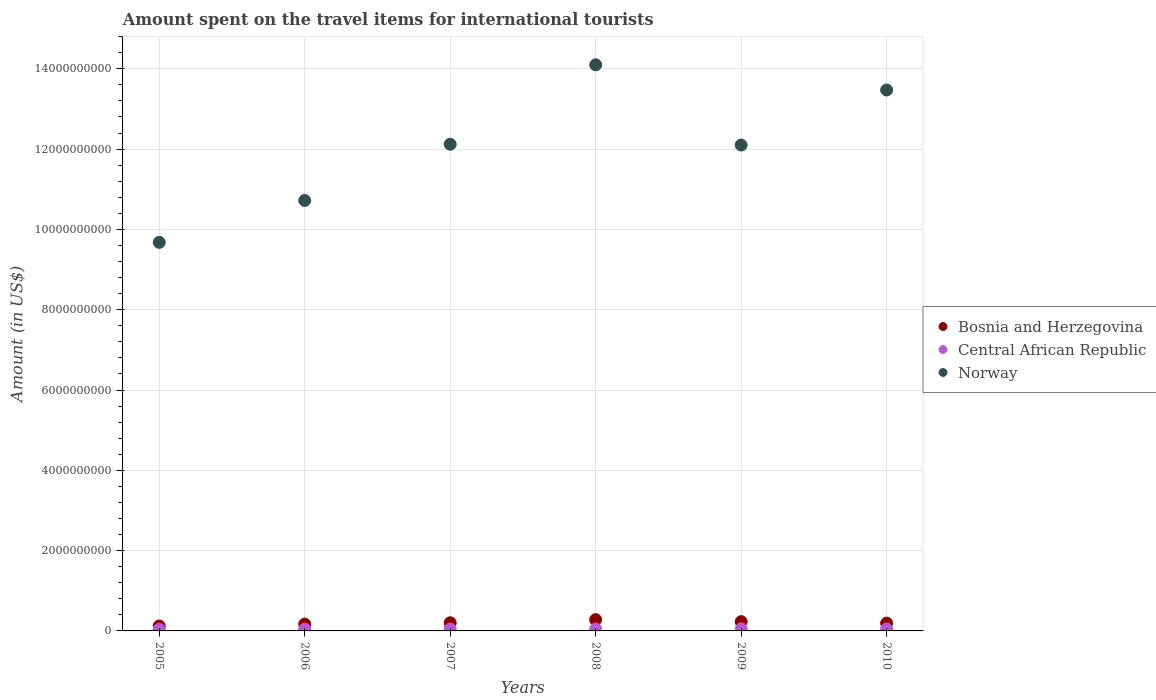How many different coloured dotlines are there?
Keep it short and to the point. 3. What is the amount spent on the travel items for international tourists in Bosnia and Herzegovina in 2008?
Offer a very short reply. 2.81e+08. Across all years, what is the maximum amount spent on the travel items for international tourists in Central African Republic?
Your answer should be very brief. 5.20e+07. Across all years, what is the minimum amount spent on the travel items for international tourists in Norway?
Provide a short and direct response. 9.68e+09. In which year was the amount spent on the travel items for international tourists in Bosnia and Herzegovina minimum?
Ensure brevity in your answer.  2005. What is the total amount spent on the travel items for international tourists in Norway in the graph?
Make the answer very short. 7.22e+1. What is the difference between the amount spent on the travel items for international tourists in Norway in 2005 and the amount spent on the travel items for international tourists in Bosnia and Herzegovina in 2008?
Offer a very short reply. 9.40e+09. What is the average amount spent on the travel items for international tourists in Norway per year?
Your answer should be compact. 1.20e+1. In the year 2009, what is the difference between the amount spent on the travel items for international tourists in Central African Republic and amount spent on the travel items for international tourists in Norway?
Offer a terse response. -1.20e+1. In how many years, is the amount spent on the travel items for international tourists in Central African Republic greater than 14000000000 US$?
Offer a very short reply. 0. What is the ratio of the amount spent on the travel items for international tourists in Bosnia and Herzegovina in 2007 to that in 2008?
Your answer should be very brief. 0.72. Is the amount spent on the travel items for international tourists in Bosnia and Herzegovina in 2005 less than that in 2008?
Keep it short and to the point. Yes. Is the difference between the amount spent on the travel items for international tourists in Central African Republic in 2006 and 2010 greater than the difference between the amount spent on the travel items for international tourists in Norway in 2006 and 2010?
Provide a short and direct response. Yes. What is the difference between the highest and the second highest amount spent on the travel items for international tourists in Bosnia and Herzegovina?
Your response must be concise. 5.00e+07. What is the difference between the highest and the lowest amount spent on the travel items for international tourists in Norway?
Offer a very short reply. 4.42e+09. Is it the case that in every year, the sum of the amount spent on the travel items for international tourists in Bosnia and Herzegovina and amount spent on the travel items for international tourists in Central African Republic  is greater than the amount spent on the travel items for international tourists in Norway?
Provide a succinct answer. No. Does the amount spent on the travel items for international tourists in Central African Republic monotonically increase over the years?
Your answer should be compact. No. Is the amount spent on the travel items for international tourists in Bosnia and Herzegovina strictly greater than the amount spent on the travel items for international tourists in Central African Republic over the years?
Your response must be concise. Yes. Is the amount spent on the travel items for international tourists in Central African Republic strictly less than the amount spent on the travel items for international tourists in Bosnia and Herzegovina over the years?
Your response must be concise. Yes. How many years are there in the graph?
Keep it short and to the point. 6. What is the difference between two consecutive major ticks on the Y-axis?
Your answer should be compact. 2.00e+09. Does the graph contain any zero values?
Ensure brevity in your answer.  No. Does the graph contain grids?
Your response must be concise. Yes. Where does the legend appear in the graph?
Provide a short and direct response. Center right. What is the title of the graph?
Provide a succinct answer. Amount spent on the travel items for international tourists. Does "Barbados" appear as one of the legend labels in the graph?
Keep it short and to the point. No. What is the label or title of the X-axis?
Your answer should be compact. Years. What is the label or title of the Y-axis?
Offer a terse response. Amount (in US$). What is the Amount (in US$) in Bosnia and Herzegovina in 2005?
Your response must be concise. 1.22e+08. What is the Amount (in US$) of Central African Republic in 2005?
Your response must be concise. 4.40e+07. What is the Amount (in US$) in Norway in 2005?
Make the answer very short. 9.68e+09. What is the Amount (in US$) of Bosnia and Herzegovina in 2006?
Keep it short and to the point. 1.70e+08. What is the Amount (in US$) of Central African Republic in 2006?
Your response must be concise. 4.40e+07. What is the Amount (in US$) of Norway in 2006?
Offer a very short reply. 1.07e+1. What is the Amount (in US$) of Bosnia and Herzegovina in 2007?
Keep it short and to the point. 2.03e+08. What is the Amount (in US$) in Central African Republic in 2007?
Provide a short and direct response. 4.80e+07. What is the Amount (in US$) of Norway in 2007?
Make the answer very short. 1.21e+1. What is the Amount (in US$) in Bosnia and Herzegovina in 2008?
Ensure brevity in your answer.  2.81e+08. What is the Amount (in US$) of Central African Republic in 2008?
Offer a terse response. 4.90e+07. What is the Amount (in US$) in Norway in 2008?
Ensure brevity in your answer.  1.41e+1. What is the Amount (in US$) of Bosnia and Herzegovina in 2009?
Offer a very short reply. 2.31e+08. What is the Amount (in US$) of Central African Republic in 2009?
Offer a terse response. 5.20e+07. What is the Amount (in US$) of Norway in 2009?
Offer a terse response. 1.21e+1. What is the Amount (in US$) in Bosnia and Herzegovina in 2010?
Provide a short and direct response. 1.94e+08. What is the Amount (in US$) in Central African Republic in 2010?
Make the answer very short. 4.90e+07. What is the Amount (in US$) of Norway in 2010?
Make the answer very short. 1.35e+1. Across all years, what is the maximum Amount (in US$) in Bosnia and Herzegovina?
Offer a very short reply. 2.81e+08. Across all years, what is the maximum Amount (in US$) in Central African Republic?
Offer a very short reply. 5.20e+07. Across all years, what is the maximum Amount (in US$) in Norway?
Your answer should be compact. 1.41e+1. Across all years, what is the minimum Amount (in US$) in Bosnia and Herzegovina?
Provide a succinct answer. 1.22e+08. Across all years, what is the minimum Amount (in US$) in Central African Republic?
Your response must be concise. 4.40e+07. Across all years, what is the minimum Amount (in US$) of Norway?
Offer a terse response. 9.68e+09. What is the total Amount (in US$) in Bosnia and Herzegovina in the graph?
Provide a short and direct response. 1.20e+09. What is the total Amount (in US$) in Central African Republic in the graph?
Your answer should be very brief. 2.86e+08. What is the total Amount (in US$) of Norway in the graph?
Provide a succinct answer. 7.22e+1. What is the difference between the Amount (in US$) in Bosnia and Herzegovina in 2005 and that in 2006?
Make the answer very short. -4.80e+07. What is the difference between the Amount (in US$) of Central African Republic in 2005 and that in 2006?
Ensure brevity in your answer.  0. What is the difference between the Amount (in US$) in Norway in 2005 and that in 2006?
Offer a terse response. -1.04e+09. What is the difference between the Amount (in US$) of Bosnia and Herzegovina in 2005 and that in 2007?
Offer a terse response. -8.10e+07. What is the difference between the Amount (in US$) in Norway in 2005 and that in 2007?
Keep it short and to the point. -2.44e+09. What is the difference between the Amount (in US$) in Bosnia and Herzegovina in 2005 and that in 2008?
Ensure brevity in your answer.  -1.59e+08. What is the difference between the Amount (in US$) of Central African Republic in 2005 and that in 2008?
Keep it short and to the point. -5.00e+06. What is the difference between the Amount (in US$) in Norway in 2005 and that in 2008?
Ensure brevity in your answer.  -4.42e+09. What is the difference between the Amount (in US$) of Bosnia and Herzegovina in 2005 and that in 2009?
Your answer should be compact. -1.09e+08. What is the difference between the Amount (in US$) of Central African Republic in 2005 and that in 2009?
Offer a terse response. -8.00e+06. What is the difference between the Amount (in US$) in Norway in 2005 and that in 2009?
Provide a succinct answer. -2.42e+09. What is the difference between the Amount (in US$) in Bosnia and Herzegovina in 2005 and that in 2010?
Offer a very short reply. -7.20e+07. What is the difference between the Amount (in US$) of Central African Republic in 2005 and that in 2010?
Offer a very short reply. -5.00e+06. What is the difference between the Amount (in US$) of Norway in 2005 and that in 2010?
Your answer should be very brief. -3.79e+09. What is the difference between the Amount (in US$) of Bosnia and Herzegovina in 2006 and that in 2007?
Ensure brevity in your answer.  -3.30e+07. What is the difference between the Amount (in US$) in Central African Republic in 2006 and that in 2007?
Ensure brevity in your answer.  -4.00e+06. What is the difference between the Amount (in US$) in Norway in 2006 and that in 2007?
Your response must be concise. -1.40e+09. What is the difference between the Amount (in US$) in Bosnia and Herzegovina in 2006 and that in 2008?
Your answer should be compact. -1.11e+08. What is the difference between the Amount (in US$) in Central African Republic in 2006 and that in 2008?
Offer a very short reply. -5.00e+06. What is the difference between the Amount (in US$) in Norway in 2006 and that in 2008?
Your answer should be compact. -3.38e+09. What is the difference between the Amount (in US$) of Bosnia and Herzegovina in 2006 and that in 2009?
Offer a terse response. -6.10e+07. What is the difference between the Amount (in US$) of Central African Republic in 2006 and that in 2009?
Your answer should be very brief. -8.00e+06. What is the difference between the Amount (in US$) in Norway in 2006 and that in 2009?
Ensure brevity in your answer.  -1.38e+09. What is the difference between the Amount (in US$) of Bosnia and Herzegovina in 2006 and that in 2010?
Give a very brief answer. -2.40e+07. What is the difference between the Amount (in US$) in Central African Republic in 2006 and that in 2010?
Make the answer very short. -5.00e+06. What is the difference between the Amount (in US$) in Norway in 2006 and that in 2010?
Your answer should be very brief. -2.75e+09. What is the difference between the Amount (in US$) in Bosnia and Herzegovina in 2007 and that in 2008?
Ensure brevity in your answer.  -7.80e+07. What is the difference between the Amount (in US$) in Central African Republic in 2007 and that in 2008?
Offer a terse response. -1.00e+06. What is the difference between the Amount (in US$) in Norway in 2007 and that in 2008?
Provide a succinct answer. -1.98e+09. What is the difference between the Amount (in US$) of Bosnia and Herzegovina in 2007 and that in 2009?
Make the answer very short. -2.80e+07. What is the difference between the Amount (in US$) in Central African Republic in 2007 and that in 2009?
Offer a very short reply. -4.00e+06. What is the difference between the Amount (in US$) in Norway in 2007 and that in 2009?
Your answer should be very brief. 2.00e+07. What is the difference between the Amount (in US$) in Bosnia and Herzegovina in 2007 and that in 2010?
Your answer should be very brief. 9.00e+06. What is the difference between the Amount (in US$) in Norway in 2007 and that in 2010?
Your response must be concise. -1.35e+09. What is the difference between the Amount (in US$) of Norway in 2008 and that in 2009?
Make the answer very short. 2.00e+09. What is the difference between the Amount (in US$) in Bosnia and Herzegovina in 2008 and that in 2010?
Offer a terse response. 8.70e+07. What is the difference between the Amount (in US$) of Central African Republic in 2008 and that in 2010?
Give a very brief answer. 0. What is the difference between the Amount (in US$) in Norway in 2008 and that in 2010?
Provide a succinct answer. 6.28e+08. What is the difference between the Amount (in US$) of Bosnia and Herzegovina in 2009 and that in 2010?
Provide a short and direct response. 3.70e+07. What is the difference between the Amount (in US$) in Norway in 2009 and that in 2010?
Your answer should be compact. -1.37e+09. What is the difference between the Amount (in US$) of Bosnia and Herzegovina in 2005 and the Amount (in US$) of Central African Republic in 2006?
Offer a very short reply. 7.80e+07. What is the difference between the Amount (in US$) in Bosnia and Herzegovina in 2005 and the Amount (in US$) in Norway in 2006?
Offer a terse response. -1.06e+1. What is the difference between the Amount (in US$) in Central African Republic in 2005 and the Amount (in US$) in Norway in 2006?
Offer a very short reply. -1.07e+1. What is the difference between the Amount (in US$) in Bosnia and Herzegovina in 2005 and the Amount (in US$) in Central African Republic in 2007?
Your answer should be very brief. 7.40e+07. What is the difference between the Amount (in US$) in Bosnia and Herzegovina in 2005 and the Amount (in US$) in Norway in 2007?
Make the answer very short. -1.20e+1. What is the difference between the Amount (in US$) in Central African Republic in 2005 and the Amount (in US$) in Norway in 2007?
Ensure brevity in your answer.  -1.21e+1. What is the difference between the Amount (in US$) of Bosnia and Herzegovina in 2005 and the Amount (in US$) of Central African Republic in 2008?
Offer a terse response. 7.30e+07. What is the difference between the Amount (in US$) of Bosnia and Herzegovina in 2005 and the Amount (in US$) of Norway in 2008?
Keep it short and to the point. -1.40e+1. What is the difference between the Amount (in US$) of Central African Republic in 2005 and the Amount (in US$) of Norway in 2008?
Make the answer very short. -1.41e+1. What is the difference between the Amount (in US$) of Bosnia and Herzegovina in 2005 and the Amount (in US$) of Central African Republic in 2009?
Offer a very short reply. 7.00e+07. What is the difference between the Amount (in US$) of Bosnia and Herzegovina in 2005 and the Amount (in US$) of Norway in 2009?
Your response must be concise. -1.20e+1. What is the difference between the Amount (in US$) of Central African Republic in 2005 and the Amount (in US$) of Norway in 2009?
Your answer should be compact. -1.21e+1. What is the difference between the Amount (in US$) of Bosnia and Herzegovina in 2005 and the Amount (in US$) of Central African Republic in 2010?
Offer a terse response. 7.30e+07. What is the difference between the Amount (in US$) of Bosnia and Herzegovina in 2005 and the Amount (in US$) of Norway in 2010?
Provide a succinct answer. -1.34e+1. What is the difference between the Amount (in US$) of Central African Republic in 2005 and the Amount (in US$) of Norway in 2010?
Keep it short and to the point. -1.34e+1. What is the difference between the Amount (in US$) in Bosnia and Herzegovina in 2006 and the Amount (in US$) in Central African Republic in 2007?
Provide a succinct answer. 1.22e+08. What is the difference between the Amount (in US$) in Bosnia and Herzegovina in 2006 and the Amount (in US$) in Norway in 2007?
Provide a short and direct response. -1.20e+1. What is the difference between the Amount (in US$) in Central African Republic in 2006 and the Amount (in US$) in Norway in 2007?
Your answer should be very brief. -1.21e+1. What is the difference between the Amount (in US$) of Bosnia and Herzegovina in 2006 and the Amount (in US$) of Central African Republic in 2008?
Provide a short and direct response. 1.21e+08. What is the difference between the Amount (in US$) in Bosnia and Herzegovina in 2006 and the Amount (in US$) in Norway in 2008?
Give a very brief answer. -1.39e+1. What is the difference between the Amount (in US$) of Central African Republic in 2006 and the Amount (in US$) of Norway in 2008?
Make the answer very short. -1.41e+1. What is the difference between the Amount (in US$) of Bosnia and Herzegovina in 2006 and the Amount (in US$) of Central African Republic in 2009?
Your answer should be very brief. 1.18e+08. What is the difference between the Amount (in US$) in Bosnia and Herzegovina in 2006 and the Amount (in US$) in Norway in 2009?
Offer a terse response. -1.19e+1. What is the difference between the Amount (in US$) of Central African Republic in 2006 and the Amount (in US$) of Norway in 2009?
Provide a succinct answer. -1.21e+1. What is the difference between the Amount (in US$) in Bosnia and Herzegovina in 2006 and the Amount (in US$) in Central African Republic in 2010?
Make the answer very short. 1.21e+08. What is the difference between the Amount (in US$) of Bosnia and Herzegovina in 2006 and the Amount (in US$) of Norway in 2010?
Provide a short and direct response. -1.33e+1. What is the difference between the Amount (in US$) of Central African Republic in 2006 and the Amount (in US$) of Norway in 2010?
Your answer should be compact. -1.34e+1. What is the difference between the Amount (in US$) of Bosnia and Herzegovina in 2007 and the Amount (in US$) of Central African Republic in 2008?
Provide a short and direct response. 1.54e+08. What is the difference between the Amount (in US$) in Bosnia and Herzegovina in 2007 and the Amount (in US$) in Norway in 2008?
Keep it short and to the point. -1.39e+1. What is the difference between the Amount (in US$) of Central African Republic in 2007 and the Amount (in US$) of Norway in 2008?
Offer a terse response. -1.41e+1. What is the difference between the Amount (in US$) in Bosnia and Herzegovina in 2007 and the Amount (in US$) in Central African Republic in 2009?
Your answer should be compact. 1.51e+08. What is the difference between the Amount (in US$) in Bosnia and Herzegovina in 2007 and the Amount (in US$) in Norway in 2009?
Keep it short and to the point. -1.19e+1. What is the difference between the Amount (in US$) of Central African Republic in 2007 and the Amount (in US$) of Norway in 2009?
Offer a terse response. -1.21e+1. What is the difference between the Amount (in US$) in Bosnia and Herzegovina in 2007 and the Amount (in US$) in Central African Republic in 2010?
Provide a succinct answer. 1.54e+08. What is the difference between the Amount (in US$) in Bosnia and Herzegovina in 2007 and the Amount (in US$) in Norway in 2010?
Your answer should be compact. -1.33e+1. What is the difference between the Amount (in US$) in Central African Republic in 2007 and the Amount (in US$) in Norway in 2010?
Offer a very short reply. -1.34e+1. What is the difference between the Amount (in US$) of Bosnia and Herzegovina in 2008 and the Amount (in US$) of Central African Republic in 2009?
Give a very brief answer. 2.29e+08. What is the difference between the Amount (in US$) of Bosnia and Herzegovina in 2008 and the Amount (in US$) of Norway in 2009?
Your answer should be very brief. -1.18e+1. What is the difference between the Amount (in US$) in Central African Republic in 2008 and the Amount (in US$) in Norway in 2009?
Offer a very short reply. -1.21e+1. What is the difference between the Amount (in US$) in Bosnia and Herzegovina in 2008 and the Amount (in US$) in Central African Republic in 2010?
Ensure brevity in your answer.  2.32e+08. What is the difference between the Amount (in US$) in Bosnia and Herzegovina in 2008 and the Amount (in US$) in Norway in 2010?
Ensure brevity in your answer.  -1.32e+1. What is the difference between the Amount (in US$) in Central African Republic in 2008 and the Amount (in US$) in Norway in 2010?
Your answer should be very brief. -1.34e+1. What is the difference between the Amount (in US$) in Bosnia and Herzegovina in 2009 and the Amount (in US$) in Central African Republic in 2010?
Provide a short and direct response. 1.82e+08. What is the difference between the Amount (in US$) in Bosnia and Herzegovina in 2009 and the Amount (in US$) in Norway in 2010?
Make the answer very short. -1.32e+1. What is the difference between the Amount (in US$) of Central African Republic in 2009 and the Amount (in US$) of Norway in 2010?
Make the answer very short. -1.34e+1. What is the average Amount (in US$) of Bosnia and Herzegovina per year?
Provide a short and direct response. 2.00e+08. What is the average Amount (in US$) of Central African Republic per year?
Your answer should be compact. 4.77e+07. What is the average Amount (in US$) in Norway per year?
Offer a terse response. 1.20e+1. In the year 2005, what is the difference between the Amount (in US$) in Bosnia and Herzegovina and Amount (in US$) in Central African Republic?
Your response must be concise. 7.80e+07. In the year 2005, what is the difference between the Amount (in US$) in Bosnia and Herzegovina and Amount (in US$) in Norway?
Your response must be concise. -9.56e+09. In the year 2005, what is the difference between the Amount (in US$) in Central African Republic and Amount (in US$) in Norway?
Your answer should be very brief. -9.63e+09. In the year 2006, what is the difference between the Amount (in US$) of Bosnia and Herzegovina and Amount (in US$) of Central African Republic?
Ensure brevity in your answer.  1.26e+08. In the year 2006, what is the difference between the Amount (in US$) of Bosnia and Herzegovina and Amount (in US$) of Norway?
Your answer should be very brief. -1.06e+1. In the year 2006, what is the difference between the Amount (in US$) of Central African Republic and Amount (in US$) of Norway?
Make the answer very short. -1.07e+1. In the year 2007, what is the difference between the Amount (in US$) in Bosnia and Herzegovina and Amount (in US$) in Central African Republic?
Offer a terse response. 1.55e+08. In the year 2007, what is the difference between the Amount (in US$) of Bosnia and Herzegovina and Amount (in US$) of Norway?
Your answer should be very brief. -1.19e+1. In the year 2007, what is the difference between the Amount (in US$) in Central African Republic and Amount (in US$) in Norway?
Provide a short and direct response. -1.21e+1. In the year 2008, what is the difference between the Amount (in US$) of Bosnia and Herzegovina and Amount (in US$) of Central African Republic?
Provide a succinct answer. 2.32e+08. In the year 2008, what is the difference between the Amount (in US$) in Bosnia and Herzegovina and Amount (in US$) in Norway?
Provide a short and direct response. -1.38e+1. In the year 2008, what is the difference between the Amount (in US$) in Central African Republic and Amount (in US$) in Norway?
Offer a very short reply. -1.41e+1. In the year 2009, what is the difference between the Amount (in US$) of Bosnia and Herzegovina and Amount (in US$) of Central African Republic?
Your response must be concise. 1.79e+08. In the year 2009, what is the difference between the Amount (in US$) of Bosnia and Herzegovina and Amount (in US$) of Norway?
Offer a very short reply. -1.19e+1. In the year 2009, what is the difference between the Amount (in US$) of Central African Republic and Amount (in US$) of Norway?
Your answer should be compact. -1.20e+1. In the year 2010, what is the difference between the Amount (in US$) of Bosnia and Herzegovina and Amount (in US$) of Central African Republic?
Offer a very short reply. 1.45e+08. In the year 2010, what is the difference between the Amount (in US$) of Bosnia and Herzegovina and Amount (in US$) of Norway?
Your response must be concise. -1.33e+1. In the year 2010, what is the difference between the Amount (in US$) of Central African Republic and Amount (in US$) of Norway?
Provide a succinct answer. -1.34e+1. What is the ratio of the Amount (in US$) in Bosnia and Herzegovina in 2005 to that in 2006?
Keep it short and to the point. 0.72. What is the ratio of the Amount (in US$) in Norway in 2005 to that in 2006?
Provide a short and direct response. 0.9. What is the ratio of the Amount (in US$) of Bosnia and Herzegovina in 2005 to that in 2007?
Give a very brief answer. 0.6. What is the ratio of the Amount (in US$) in Norway in 2005 to that in 2007?
Your answer should be very brief. 0.8. What is the ratio of the Amount (in US$) in Bosnia and Herzegovina in 2005 to that in 2008?
Offer a terse response. 0.43. What is the ratio of the Amount (in US$) in Central African Republic in 2005 to that in 2008?
Provide a short and direct response. 0.9. What is the ratio of the Amount (in US$) in Norway in 2005 to that in 2008?
Ensure brevity in your answer.  0.69. What is the ratio of the Amount (in US$) in Bosnia and Herzegovina in 2005 to that in 2009?
Your answer should be compact. 0.53. What is the ratio of the Amount (in US$) of Central African Republic in 2005 to that in 2009?
Offer a very short reply. 0.85. What is the ratio of the Amount (in US$) in Norway in 2005 to that in 2009?
Offer a terse response. 0.8. What is the ratio of the Amount (in US$) in Bosnia and Herzegovina in 2005 to that in 2010?
Offer a terse response. 0.63. What is the ratio of the Amount (in US$) in Central African Republic in 2005 to that in 2010?
Your response must be concise. 0.9. What is the ratio of the Amount (in US$) of Norway in 2005 to that in 2010?
Keep it short and to the point. 0.72. What is the ratio of the Amount (in US$) of Bosnia and Herzegovina in 2006 to that in 2007?
Offer a very short reply. 0.84. What is the ratio of the Amount (in US$) in Norway in 2006 to that in 2007?
Offer a terse response. 0.88. What is the ratio of the Amount (in US$) of Bosnia and Herzegovina in 2006 to that in 2008?
Provide a succinct answer. 0.6. What is the ratio of the Amount (in US$) of Central African Republic in 2006 to that in 2008?
Make the answer very short. 0.9. What is the ratio of the Amount (in US$) in Norway in 2006 to that in 2008?
Your answer should be very brief. 0.76. What is the ratio of the Amount (in US$) of Bosnia and Herzegovina in 2006 to that in 2009?
Provide a succinct answer. 0.74. What is the ratio of the Amount (in US$) of Central African Republic in 2006 to that in 2009?
Your answer should be compact. 0.85. What is the ratio of the Amount (in US$) in Norway in 2006 to that in 2009?
Offer a terse response. 0.89. What is the ratio of the Amount (in US$) of Bosnia and Herzegovina in 2006 to that in 2010?
Offer a very short reply. 0.88. What is the ratio of the Amount (in US$) of Central African Republic in 2006 to that in 2010?
Offer a terse response. 0.9. What is the ratio of the Amount (in US$) of Norway in 2006 to that in 2010?
Provide a short and direct response. 0.8. What is the ratio of the Amount (in US$) of Bosnia and Herzegovina in 2007 to that in 2008?
Offer a very short reply. 0.72. What is the ratio of the Amount (in US$) of Central African Republic in 2007 to that in 2008?
Your answer should be very brief. 0.98. What is the ratio of the Amount (in US$) in Norway in 2007 to that in 2008?
Offer a terse response. 0.86. What is the ratio of the Amount (in US$) of Bosnia and Herzegovina in 2007 to that in 2009?
Your answer should be compact. 0.88. What is the ratio of the Amount (in US$) in Norway in 2007 to that in 2009?
Give a very brief answer. 1. What is the ratio of the Amount (in US$) of Bosnia and Herzegovina in 2007 to that in 2010?
Keep it short and to the point. 1.05. What is the ratio of the Amount (in US$) of Central African Republic in 2007 to that in 2010?
Your answer should be compact. 0.98. What is the ratio of the Amount (in US$) in Norway in 2007 to that in 2010?
Offer a terse response. 0.9. What is the ratio of the Amount (in US$) of Bosnia and Herzegovina in 2008 to that in 2009?
Your answer should be compact. 1.22. What is the ratio of the Amount (in US$) in Central African Republic in 2008 to that in 2009?
Offer a very short reply. 0.94. What is the ratio of the Amount (in US$) of Norway in 2008 to that in 2009?
Offer a very short reply. 1.17. What is the ratio of the Amount (in US$) in Bosnia and Herzegovina in 2008 to that in 2010?
Ensure brevity in your answer.  1.45. What is the ratio of the Amount (in US$) in Central African Republic in 2008 to that in 2010?
Offer a very short reply. 1. What is the ratio of the Amount (in US$) of Norway in 2008 to that in 2010?
Provide a succinct answer. 1.05. What is the ratio of the Amount (in US$) of Bosnia and Herzegovina in 2009 to that in 2010?
Your response must be concise. 1.19. What is the ratio of the Amount (in US$) of Central African Republic in 2009 to that in 2010?
Your answer should be compact. 1.06. What is the ratio of the Amount (in US$) in Norway in 2009 to that in 2010?
Provide a short and direct response. 0.9. What is the difference between the highest and the second highest Amount (in US$) of Bosnia and Herzegovina?
Keep it short and to the point. 5.00e+07. What is the difference between the highest and the second highest Amount (in US$) in Norway?
Your answer should be very brief. 6.28e+08. What is the difference between the highest and the lowest Amount (in US$) in Bosnia and Herzegovina?
Provide a short and direct response. 1.59e+08. What is the difference between the highest and the lowest Amount (in US$) in Central African Republic?
Offer a terse response. 8.00e+06. What is the difference between the highest and the lowest Amount (in US$) of Norway?
Provide a succinct answer. 4.42e+09. 